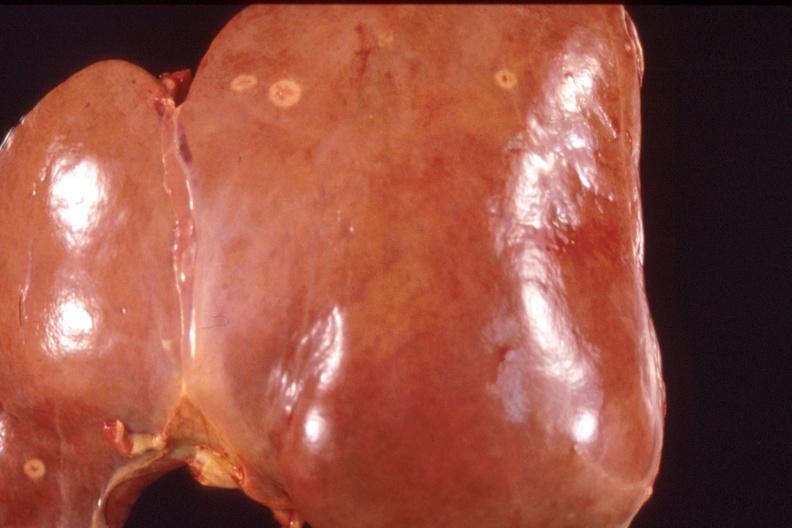does this image show liver, metastatic breast cancer?
Answer the question using a single word or phrase. Yes 